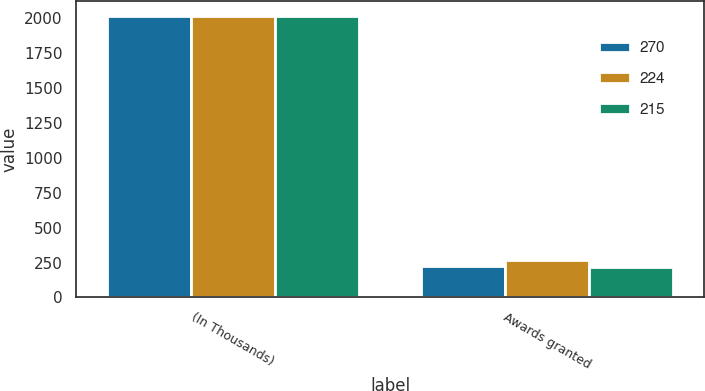Convert chart. <chart><loc_0><loc_0><loc_500><loc_500><stacked_bar_chart><ecel><fcel>(In Thousands)<fcel>Awards granted<nl><fcel>270<fcel>2015<fcel>224<nl><fcel>224<fcel>2014<fcel>270<nl><fcel>215<fcel>2013<fcel>215<nl></chart> 